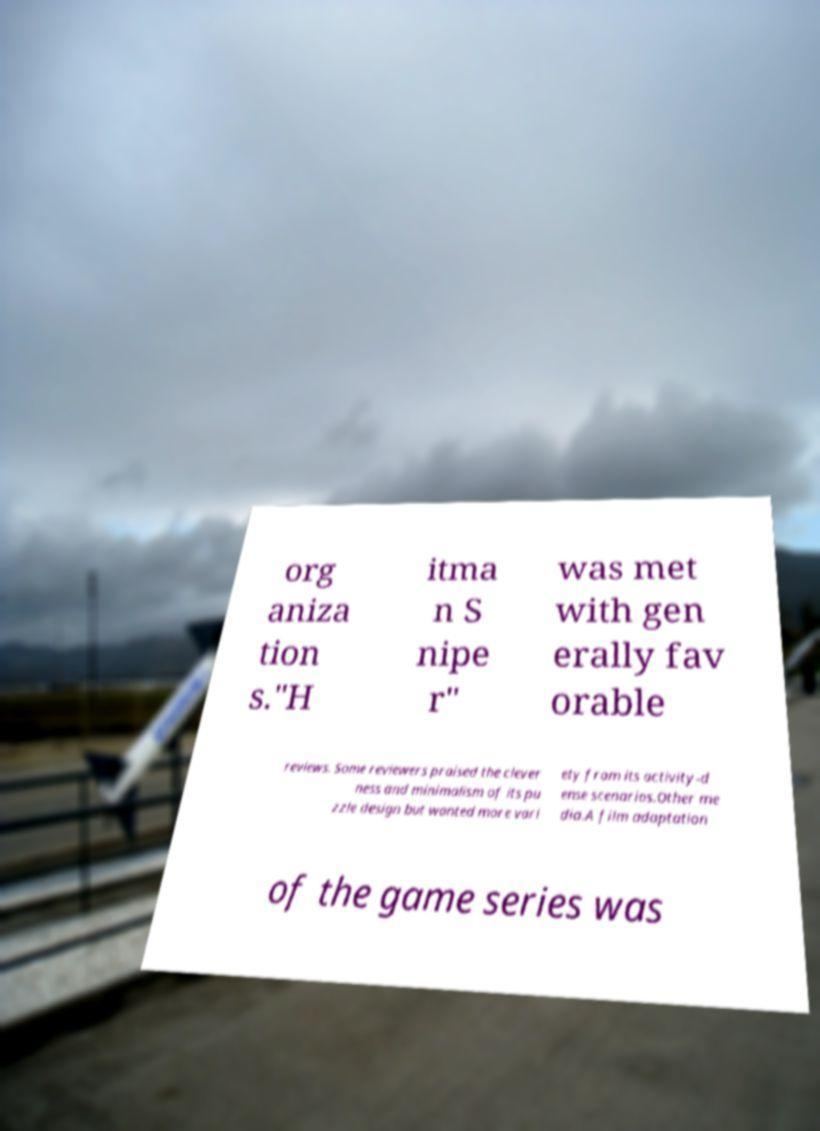I need the written content from this picture converted into text. Can you do that? org aniza tion s."H itma n S nipe r" was met with gen erally fav orable reviews. Some reviewers praised the clever ness and minimalism of its pu zzle design but wanted more vari ety from its activity-d ense scenarios.Other me dia.A film adaptation of the game series was 